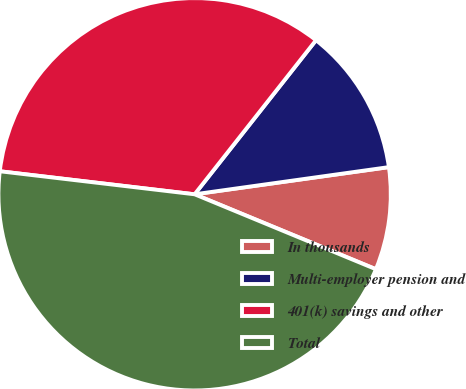Convert chart. <chart><loc_0><loc_0><loc_500><loc_500><pie_chart><fcel>In thousands<fcel>Multi-employer pension and<fcel>401(k) savings and other<fcel>Total<nl><fcel>8.45%<fcel>12.17%<fcel>33.75%<fcel>45.64%<nl></chart> 